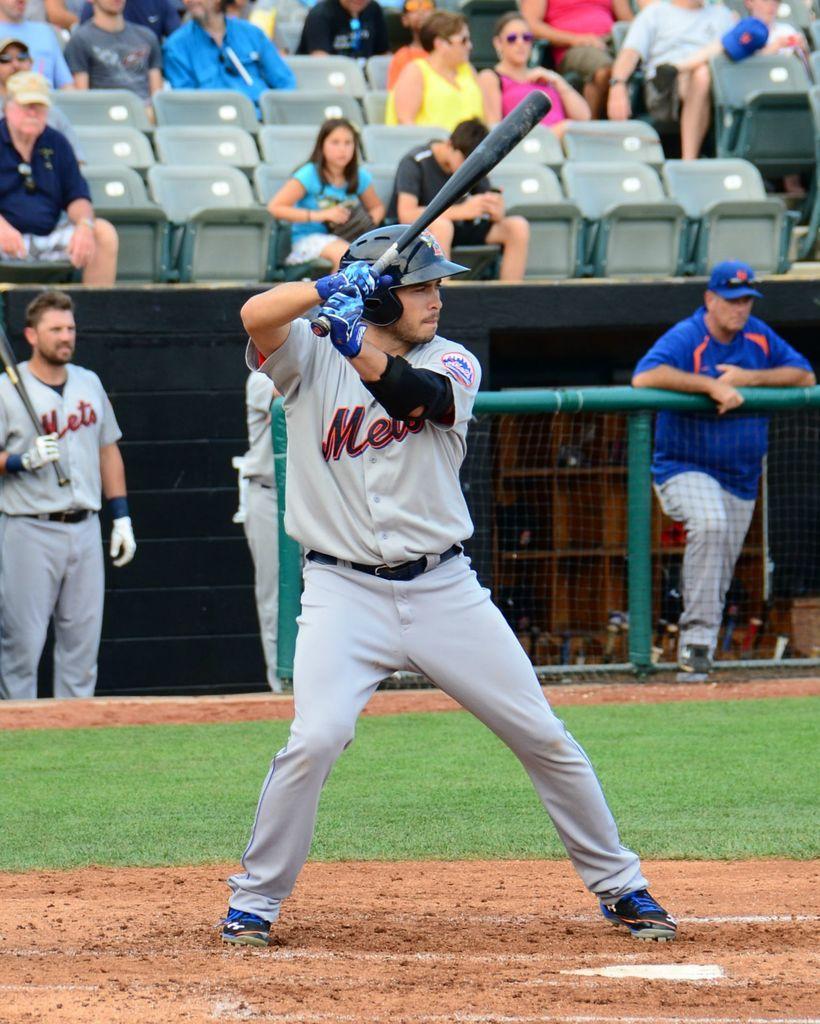Can you describe this image briefly? This image consists of a man wearing white dress and playing baseball. In the background, there are many people sitting in the chairs. At the bottom, there is ground. 